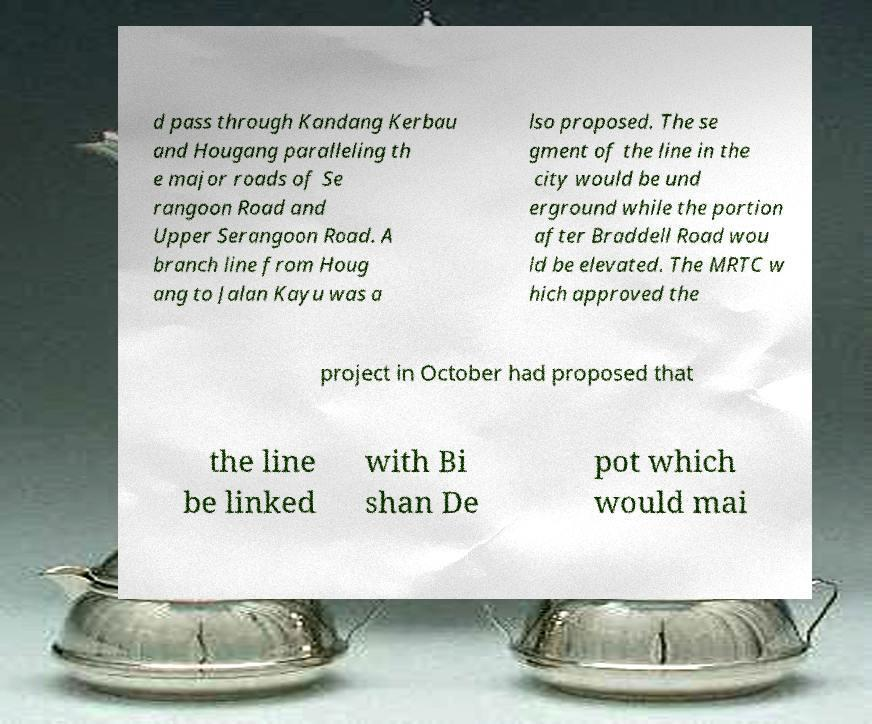Please read and relay the text visible in this image. What does it say? d pass through Kandang Kerbau and Hougang paralleling th e major roads of Se rangoon Road and Upper Serangoon Road. A branch line from Houg ang to Jalan Kayu was a lso proposed. The se gment of the line in the city would be und erground while the portion after Braddell Road wou ld be elevated. The MRTC w hich approved the project in October had proposed that the line be linked with Bi shan De pot which would mai 